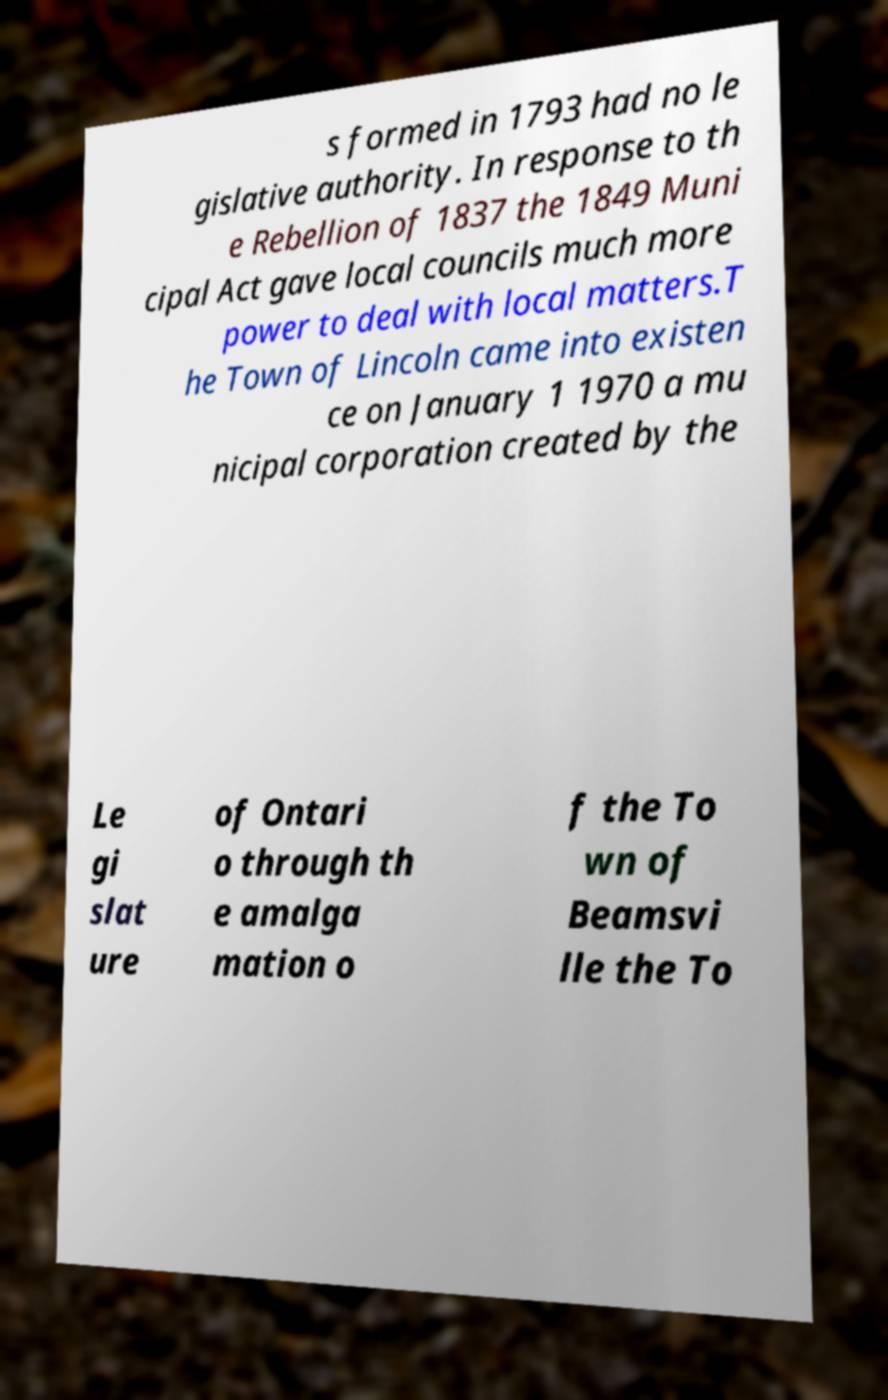Could you assist in decoding the text presented in this image and type it out clearly? s formed in 1793 had no le gislative authority. In response to th e Rebellion of 1837 the 1849 Muni cipal Act gave local councils much more power to deal with local matters.T he Town of Lincoln came into existen ce on January 1 1970 a mu nicipal corporation created by the Le gi slat ure of Ontari o through th e amalga mation o f the To wn of Beamsvi lle the To 